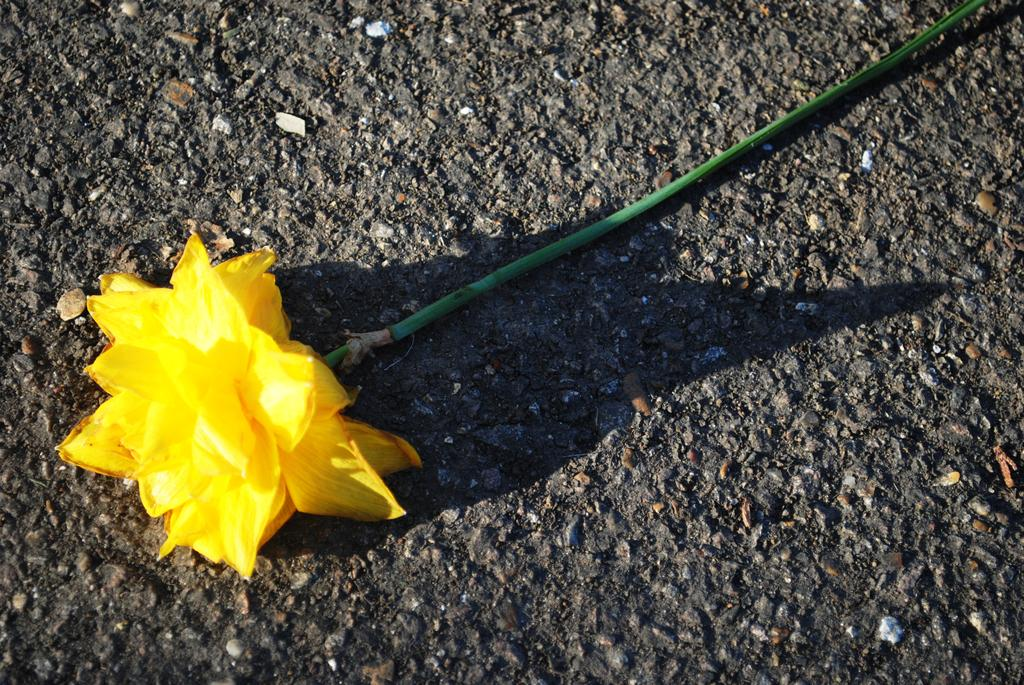What type of flower is in the image? There is a yellow flower in the image. What part of the flower connects it to the ground? The flower has a stem that connects it to the ground. Where is the flower and stem located in the image? The flower and stem are on the ground in the image. Can you see a boy rubbing his lips on the flower in the image? There is no boy or any action involving lips in the image; it only features a yellow flower with a stem on the ground. 